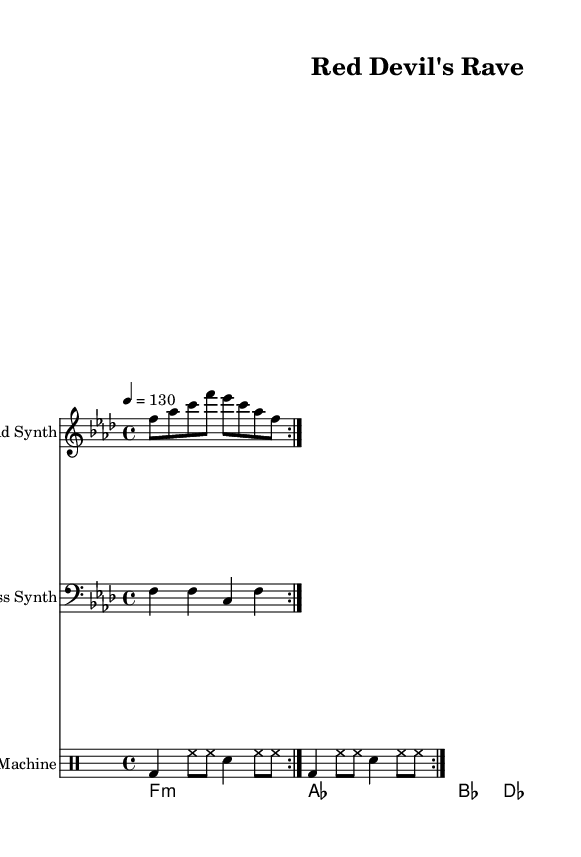What is the key signature of this music? The key signature is indicated at the beginning of the staff where it shows F minor, which has four flats (B♭, E♭, A♭, and D♭).
Answer: F minor What is the time signature of this piece? The time signature is located next to the key signature and reads 4/4, indicating four beats per measure with a quarter note getting one beat.
Answer: 4/4 What is the tempo marking of the piece? The tempo marking, placed above the staff, instructs the performer to play at a speed of 130 beats per minute.
Answer: 130 How many measures does the lead synth part repeat? The repeat markings indicate that the lead synth section should be played twice. The repeat sign appears above the relevant measures.
Answer: 2 What type of chords are used in the pad synth progression? The pad synth shows a progression of minor and major chords, specifically indicating an F minor chord followed by A♭, B♭, and D♭ major.
Answer: F minor, A♭, B♭, D♭ What percussion instruments are indicated on the drum pattern? The drum pattern denotes a bass drum, hi-hat, and snare drum, which are standard elements in electronic drum patterns, shown through specific notation for each instrument.
Answer: Bass drum, hi-hat, snare What overall genre does this piece embody? The composition is geared towards electronic music, particularly a style of techno influenced by the high energy akin to a football match atmosphere.
Answer: Electronic 